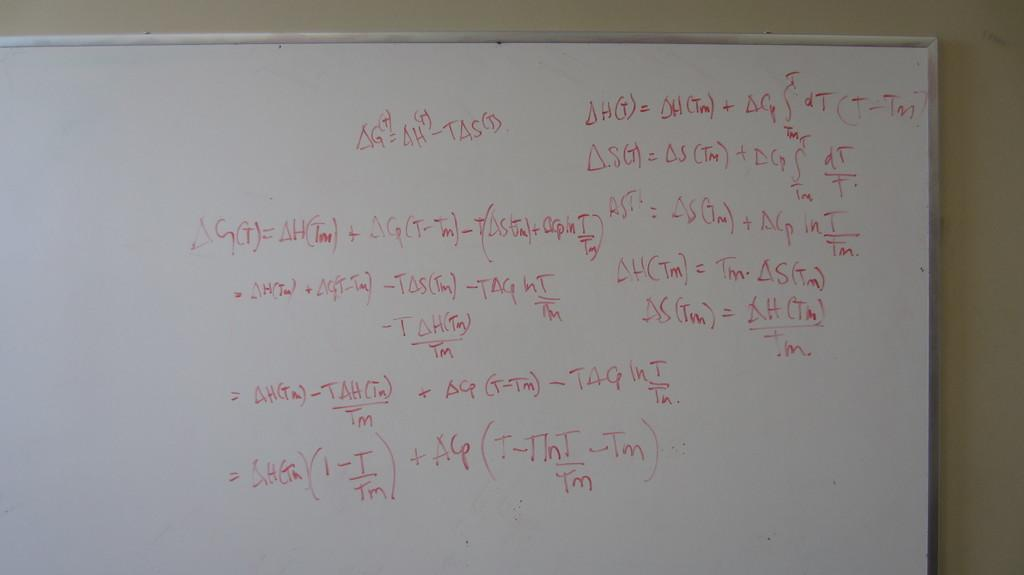<image>
Present a compact description of the photo's key features. White board that has an equation which says "TAS". 